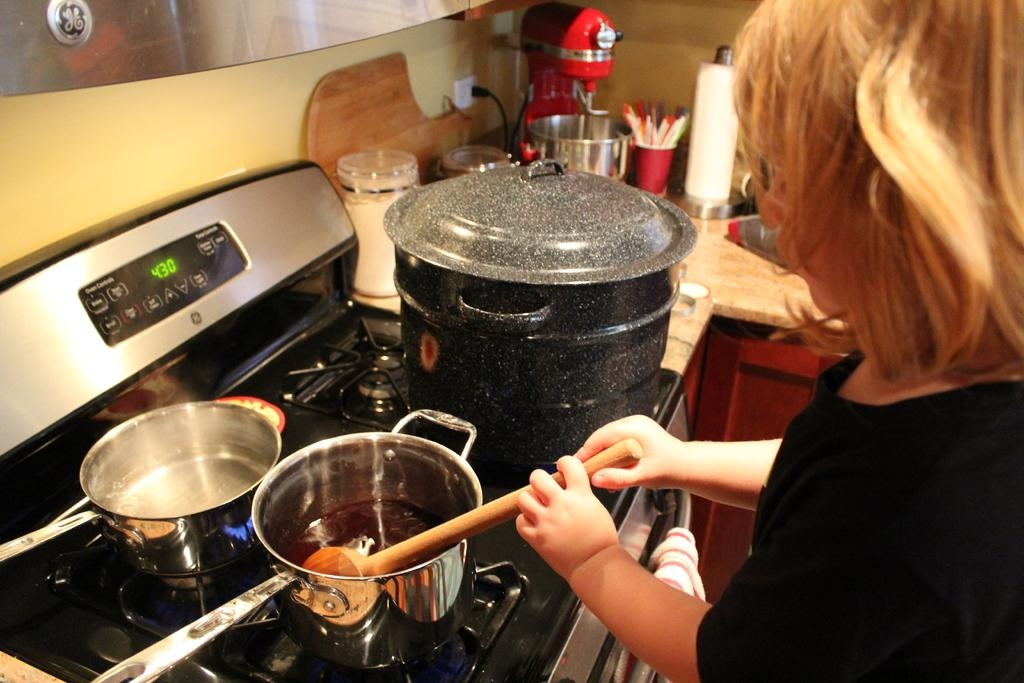Provide a one-sentence caption for the provided image. The digital display of an oven shows the time of 4:30. 